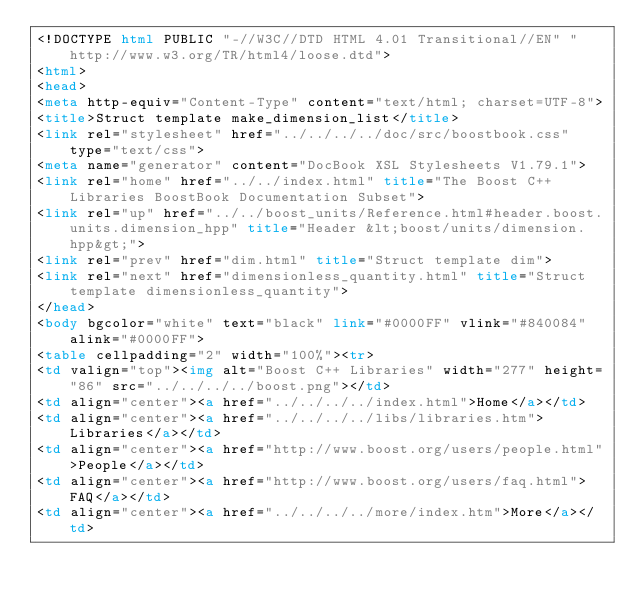Convert code to text. <code><loc_0><loc_0><loc_500><loc_500><_HTML_><!DOCTYPE html PUBLIC "-//W3C//DTD HTML 4.01 Transitional//EN" "http://www.w3.org/TR/html4/loose.dtd">
<html>
<head>
<meta http-equiv="Content-Type" content="text/html; charset=UTF-8">
<title>Struct template make_dimension_list</title>
<link rel="stylesheet" href="../../../../doc/src/boostbook.css" type="text/css">
<meta name="generator" content="DocBook XSL Stylesheets V1.79.1">
<link rel="home" href="../../index.html" title="The Boost C++ Libraries BoostBook Documentation Subset">
<link rel="up" href="../../boost_units/Reference.html#header.boost.units.dimension_hpp" title="Header &lt;boost/units/dimension.hpp&gt;">
<link rel="prev" href="dim.html" title="Struct template dim">
<link rel="next" href="dimensionless_quantity.html" title="Struct template dimensionless_quantity">
</head>
<body bgcolor="white" text="black" link="#0000FF" vlink="#840084" alink="#0000FF">
<table cellpadding="2" width="100%"><tr>
<td valign="top"><img alt="Boost C++ Libraries" width="277" height="86" src="../../../../boost.png"></td>
<td align="center"><a href="../../../../index.html">Home</a></td>
<td align="center"><a href="../../../../libs/libraries.htm">Libraries</a></td>
<td align="center"><a href="http://www.boost.org/users/people.html">People</a></td>
<td align="center"><a href="http://www.boost.org/users/faq.html">FAQ</a></td>
<td align="center"><a href="../../../../more/index.htm">More</a></td></code> 